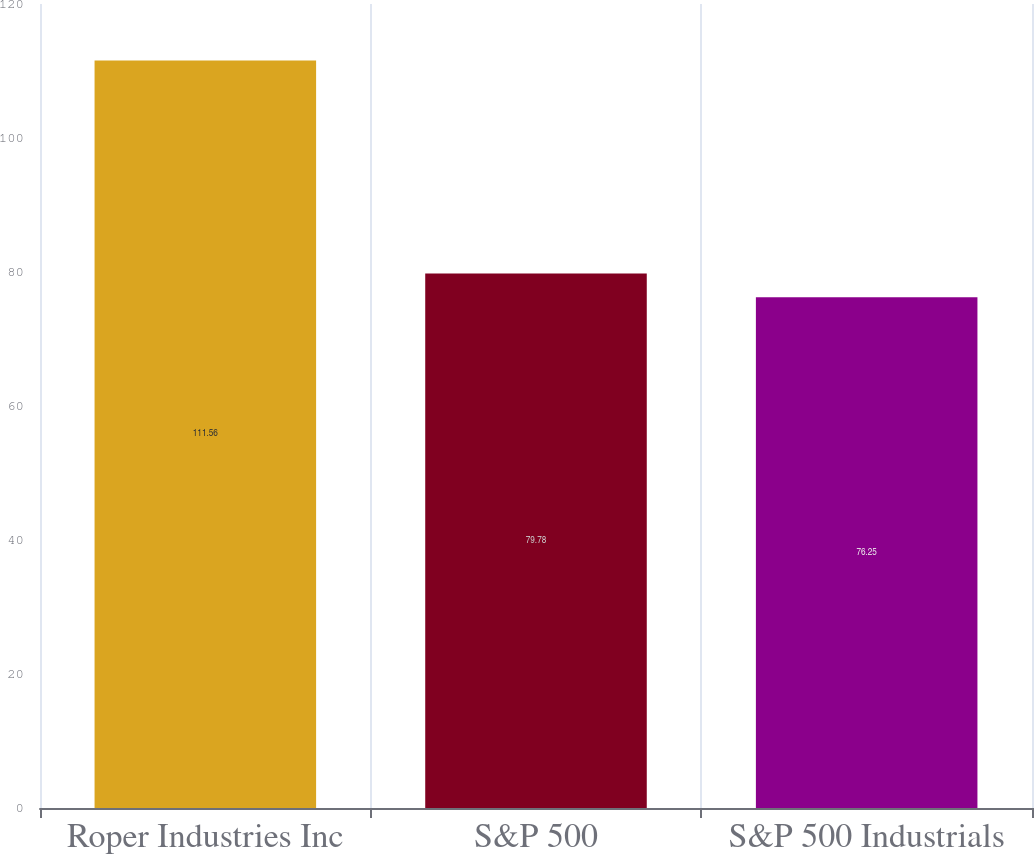Convert chart. <chart><loc_0><loc_0><loc_500><loc_500><bar_chart><fcel>Roper Industries Inc<fcel>S&P 500<fcel>S&P 500 Industrials<nl><fcel>111.56<fcel>79.78<fcel>76.25<nl></chart> 